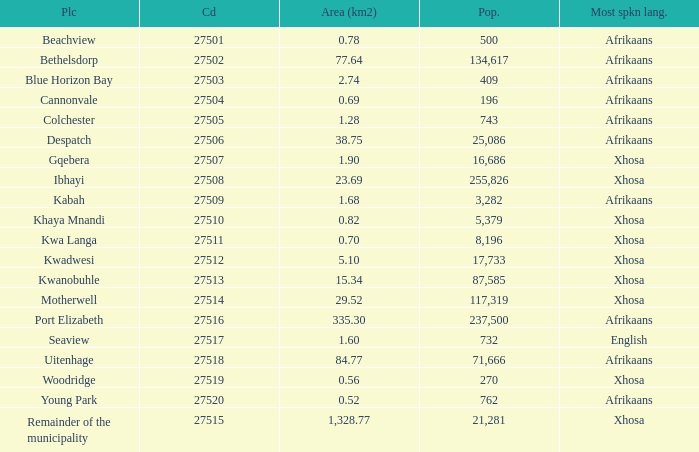What is the place that speaks xhosa, has a population less than 87,585, an area smaller than 1.28 squared kilometers, and a code larger than 27504? Khaya Mnandi, Kwa Langa, Woodridge. 